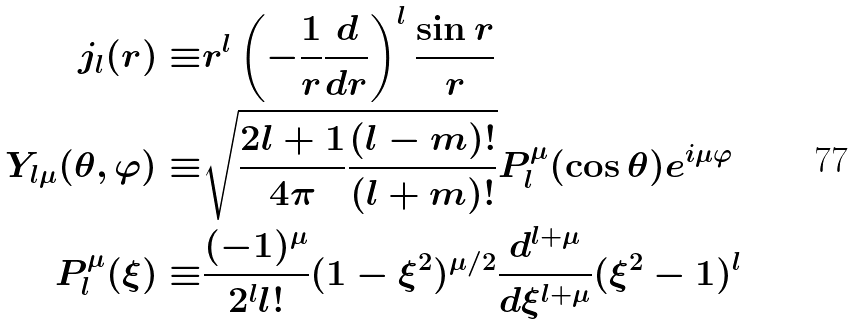Convert formula to latex. <formula><loc_0><loc_0><loc_500><loc_500>j _ { l } ( r ) \equiv & r ^ { l } \left ( - \frac { 1 } { r } \frac { d } { d r } \right ) ^ { l } \frac { \sin r } { r } \\ Y _ { l \mu } ( \theta , \varphi ) \equiv & \sqrt { \frac { 2 l + 1 } { 4 \pi } \frac { ( l - m ) ! } { ( l + m ) ! } } P _ { l } ^ { \mu } ( \cos \theta ) e ^ { i \mu \varphi } \\ P _ { l } ^ { \mu } ( \xi ) \equiv & \frac { ( - 1 ) ^ { \mu } } { 2 ^ { l } l ! } ( 1 - \xi ^ { 2 } ) ^ { \mu / 2 } \frac { d ^ { l + \mu } } { d \xi ^ { l + \mu } } ( \xi ^ { 2 } - 1 ) ^ { l }</formula> 